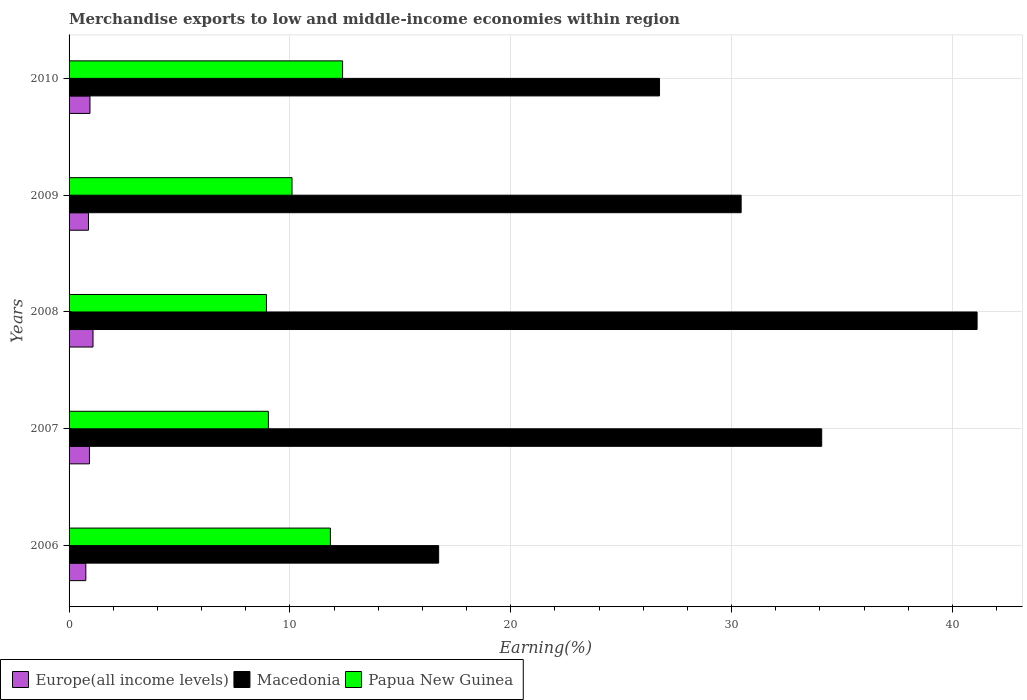How many groups of bars are there?
Your response must be concise. 5. Are the number of bars per tick equal to the number of legend labels?
Give a very brief answer. Yes. Are the number of bars on each tick of the Y-axis equal?
Give a very brief answer. Yes. How many bars are there on the 1st tick from the top?
Keep it short and to the point. 3. How many bars are there on the 4th tick from the bottom?
Offer a very short reply. 3. What is the percentage of amount earned from merchandise exports in Europe(all income levels) in 2008?
Your answer should be compact. 1.08. Across all years, what is the maximum percentage of amount earned from merchandise exports in Papua New Guinea?
Make the answer very short. 12.39. Across all years, what is the minimum percentage of amount earned from merchandise exports in Macedonia?
Make the answer very short. 16.74. In which year was the percentage of amount earned from merchandise exports in Papua New Guinea maximum?
Your answer should be compact. 2010. What is the total percentage of amount earned from merchandise exports in Papua New Guinea in the graph?
Ensure brevity in your answer.  52.28. What is the difference between the percentage of amount earned from merchandise exports in Europe(all income levels) in 2006 and that in 2010?
Give a very brief answer. -0.19. What is the difference between the percentage of amount earned from merchandise exports in Macedonia in 2006 and the percentage of amount earned from merchandise exports in Papua New Guinea in 2010?
Provide a short and direct response. 4.35. What is the average percentage of amount earned from merchandise exports in Papua New Guinea per year?
Keep it short and to the point. 10.46. In the year 2008, what is the difference between the percentage of amount earned from merchandise exports in Papua New Guinea and percentage of amount earned from merchandise exports in Macedonia?
Provide a short and direct response. -32.18. In how many years, is the percentage of amount earned from merchandise exports in Papua New Guinea greater than 24 %?
Provide a short and direct response. 0. What is the ratio of the percentage of amount earned from merchandise exports in Papua New Guinea in 2007 to that in 2009?
Your response must be concise. 0.89. Is the percentage of amount earned from merchandise exports in Papua New Guinea in 2009 less than that in 2010?
Your answer should be very brief. Yes. What is the difference between the highest and the second highest percentage of amount earned from merchandise exports in Europe(all income levels)?
Your answer should be very brief. 0.14. What is the difference between the highest and the lowest percentage of amount earned from merchandise exports in Papua New Guinea?
Provide a short and direct response. 3.45. Is the sum of the percentage of amount earned from merchandise exports in Europe(all income levels) in 2007 and 2010 greater than the maximum percentage of amount earned from merchandise exports in Papua New Guinea across all years?
Offer a terse response. No. What does the 2nd bar from the top in 2006 represents?
Offer a very short reply. Macedonia. What does the 2nd bar from the bottom in 2008 represents?
Provide a succinct answer. Macedonia. Is it the case that in every year, the sum of the percentage of amount earned from merchandise exports in Europe(all income levels) and percentage of amount earned from merchandise exports in Macedonia is greater than the percentage of amount earned from merchandise exports in Papua New Guinea?
Offer a very short reply. Yes. How many bars are there?
Make the answer very short. 15. How many years are there in the graph?
Provide a succinct answer. 5. What is the difference between two consecutive major ticks on the X-axis?
Ensure brevity in your answer.  10. Are the values on the major ticks of X-axis written in scientific E-notation?
Provide a succinct answer. No. Does the graph contain any zero values?
Ensure brevity in your answer.  No. Does the graph contain grids?
Provide a succinct answer. Yes. How many legend labels are there?
Keep it short and to the point. 3. How are the legend labels stacked?
Your answer should be compact. Horizontal. What is the title of the graph?
Offer a terse response. Merchandise exports to low and middle-income economies within region. Does "Kazakhstan" appear as one of the legend labels in the graph?
Provide a succinct answer. No. What is the label or title of the X-axis?
Provide a succinct answer. Earning(%). What is the Earning(%) in Europe(all income levels) in 2006?
Your response must be concise. 0.76. What is the Earning(%) of Macedonia in 2006?
Provide a short and direct response. 16.74. What is the Earning(%) in Papua New Guinea in 2006?
Keep it short and to the point. 11.83. What is the Earning(%) of Europe(all income levels) in 2007?
Your response must be concise. 0.92. What is the Earning(%) of Macedonia in 2007?
Keep it short and to the point. 34.08. What is the Earning(%) in Papua New Guinea in 2007?
Make the answer very short. 9.03. What is the Earning(%) in Europe(all income levels) in 2008?
Your answer should be compact. 1.08. What is the Earning(%) in Macedonia in 2008?
Offer a terse response. 41.12. What is the Earning(%) in Papua New Guinea in 2008?
Give a very brief answer. 8.94. What is the Earning(%) in Europe(all income levels) in 2009?
Your answer should be compact. 0.88. What is the Earning(%) of Macedonia in 2009?
Ensure brevity in your answer.  30.43. What is the Earning(%) in Papua New Guinea in 2009?
Give a very brief answer. 10.1. What is the Earning(%) of Europe(all income levels) in 2010?
Your response must be concise. 0.95. What is the Earning(%) in Macedonia in 2010?
Provide a short and direct response. 26.74. What is the Earning(%) in Papua New Guinea in 2010?
Your answer should be compact. 12.39. Across all years, what is the maximum Earning(%) in Europe(all income levels)?
Give a very brief answer. 1.08. Across all years, what is the maximum Earning(%) of Macedonia?
Make the answer very short. 41.12. Across all years, what is the maximum Earning(%) of Papua New Guinea?
Keep it short and to the point. 12.39. Across all years, what is the minimum Earning(%) in Europe(all income levels)?
Keep it short and to the point. 0.76. Across all years, what is the minimum Earning(%) in Macedonia?
Offer a very short reply. 16.74. Across all years, what is the minimum Earning(%) of Papua New Guinea?
Offer a terse response. 8.94. What is the total Earning(%) in Europe(all income levels) in the graph?
Keep it short and to the point. 4.59. What is the total Earning(%) in Macedonia in the graph?
Give a very brief answer. 149.11. What is the total Earning(%) in Papua New Guinea in the graph?
Offer a terse response. 52.28. What is the difference between the Earning(%) of Europe(all income levels) in 2006 and that in 2007?
Your response must be concise. -0.16. What is the difference between the Earning(%) of Macedonia in 2006 and that in 2007?
Make the answer very short. -17.35. What is the difference between the Earning(%) in Papua New Guinea in 2006 and that in 2007?
Offer a very short reply. 2.81. What is the difference between the Earning(%) of Europe(all income levels) in 2006 and that in 2008?
Make the answer very short. -0.33. What is the difference between the Earning(%) in Macedonia in 2006 and that in 2008?
Offer a very short reply. -24.38. What is the difference between the Earning(%) in Papua New Guinea in 2006 and that in 2008?
Offer a very short reply. 2.89. What is the difference between the Earning(%) in Europe(all income levels) in 2006 and that in 2009?
Offer a terse response. -0.12. What is the difference between the Earning(%) of Macedonia in 2006 and that in 2009?
Make the answer very short. -13.7. What is the difference between the Earning(%) of Papua New Guinea in 2006 and that in 2009?
Offer a very short reply. 1.74. What is the difference between the Earning(%) of Europe(all income levels) in 2006 and that in 2010?
Your answer should be compact. -0.19. What is the difference between the Earning(%) of Macedonia in 2006 and that in 2010?
Your answer should be compact. -10. What is the difference between the Earning(%) of Papua New Guinea in 2006 and that in 2010?
Ensure brevity in your answer.  -0.55. What is the difference between the Earning(%) in Europe(all income levels) in 2007 and that in 2008?
Offer a very short reply. -0.16. What is the difference between the Earning(%) of Macedonia in 2007 and that in 2008?
Your answer should be very brief. -7.04. What is the difference between the Earning(%) of Papua New Guinea in 2007 and that in 2008?
Offer a terse response. 0.09. What is the difference between the Earning(%) in Europe(all income levels) in 2007 and that in 2009?
Your response must be concise. 0.04. What is the difference between the Earning(%) of Macedonia in 2007 and that in 2009?
Ensure brevity in your answer.  3.65. What is the difference between the Earning(%) in Papua New Guinea in 2007 and that in 2009?
Provide a succinct answer. -1.07. What is the difference between the Earning(%) of Europe(all income levels) in 2007 and that in 2010?
Offer a terse response. -0.02. What is the difference between the Earning(%) of Macedonia in 2007 and that in 2010?
Make the answer very short. 7.34. What is the difference between the Earning(%) of Papua New Guinea in 2007 and that in 2010?
Provide a short and direct response. -3.36. What is the difference between the Earning(%) in Europe(all income levels) in 2008 and that in 2009?
Offer a very short reply. 0.2. What is the difference between the Earning(%) in Macedonia in 2008 and that in 2009?
Offer a very short reply. 10.68. What is the difference between the Earning(%) in Papua New Guinea in 2008 and that in 2009?
Your response must be concise. -1.16. What is the difference between the Earning(%) in Europe(all income levels) in 2008 and that in 2010?
Your response must be concise. 0.14. What is the difference between the Earning(%) in Macedonia in 2008 and that in 2010?
Your response must be concise. 14.38. What is the difference between the Earning(%) of Papua New Guinea in 2008 and that in 2010?
Provide a short and direct response. -3.45. What is the difference between the Earning(%) in Europe(all income levels) in 2009 and that in 2010?
Offer a terse response. -0.07. What is the difference between the Earning(%) in Macedonia in 2009 and that in 2010?
Give a very brief answer. 3.7. What is the difference between the Earning(%) of Papua New Guinea in 2009 and that in 2010?
Your response must be concise. -2.29. What is the difference between the Earning(%) of Europe(all income levels) in 2006 and the Earning(%) of Macedonia in 2007?
Give a very brief answer. -33.32. What is the difference between the Earning(%) in Europe(all income levels) in 2006 and the Earning(%) in Papua New Guinea in 2007?
Offer a very short reply. -8.27. What is the difference between the Earning(%) in Macedonia in 2006 and the Earning(%) in Papua New Guinea in 2007?
Provide a succinct answer. 7.71. What is the difference between the Earning(%) of Europe(all income levels) in 2006 and the Earning(%) of Macedonia in 2008?
Your answer should be very brief. -40.36. What is the difference between the Earning(%) of Europe(all income levels) in 2006 and the Earning(%) of Papua New Guinea in 2008?
Provide a short and direct response. -8.18. What is the difference between the Earning(%) in Macedonia in 2006 and the Earning(%) in Papua New Guinea in 2008?
Your answer should be compact. 7.8. What is the difference between the Earning(%) of Europe(all income levels) in 2006 and the Earning(%) of Macedonia in 2009?
Your response must be concise. -29.68. What is the difference between the Earning(%) of Europe(all income levels) in 2006 and the Earning(%) of Papua New Guinea in 2009?
Offer a very short reply. -9.34. What is the difference between the Earning(%) in Macedonia in 2006 and the Earning(%) in Papua New Guinea in 2009?
Offer a very short reply. 6.64. What is the difference between the Earning(%) in Europe(all income levels) in 2006 and the Earning(%) in Macedonia in 2010?
Make the answer very short. -25.98. What is the difference between the Earning(%) of Europe(all income levels) in 2006 and the Earning(%) of Papua New Guinea in 2010?
Offer a terse response. -11.63. What is the difference between the Earning(%) of Macedonia in 2006 and the Earning(%) of Papua New Guinea in 2010?
Ensure brevity in your answer.  4.35. What is the difference between the Earning(%) of Europe(all income levels) in 2007 and the Earning(%) of Macedonia in 2008?
Your response must be concise. -40.2. What is the difference between the Earning(%) in Europe(all income levels) in 2007 and the Earning(%) in Papua New Guinea in 2008?
Provide a short and direct response. -8.02. What is the difference between the Earning(%) of Macedonia in 2007 and the Earning(%) of Papua New Guinea in 2008?
Offer a terse response. 25.14. What is the difference between the Earning(%) of Europe(all income levels) in 2007 and the Earning(%) of Macedonia in 2009?
Keep it short and to the point. -29.51. What is the difference between the Earning(%) of Europe(all income levels) in 2007 and the Earning(%) of Papua New Guinea in 2009?
Provide a succinct answer. -9.17. What is the difference between the Earning(%) of Macedonia in 2007 and the Earning(%) of Papua New Guinea in 2009?
Your answer should be compact. 23.99. What is the difference between the Earning(%) of Europe(all income levels) in 2007 and the Earning(%) of Macedonia in 2010?
Your response must be concise. -25.82. What is the difference between the Earning(%) of Europe(all income levels) in 2007 and the Earning(%) of Papua New Guinea in 2010?
Give a very brief answer. -11.46. What is the difference between the Earning(%) in Macedonia in 2007 and the Earning(%) in Papua New Guinea in 2010?
Your response must be concise. 21.7. What is the difference between the Earning(%) in Europe(all income levels) in 2008 and the Earning(%) in Macedonia in 2009?
Your answer should be compact. -29.35. What is the difference between the Earning(%) in Europe(all income levels) in 2008 and the Earning(%) in Papua New Guinea in 2009?
Your answer should be very brief. -9.01. What is the difference between the Earning(%) of Macedonia in 2008 and the Earning(%) of Papua New Guinea in 2009?
Keep it short and to the point. 31.02. What is the difference between the Earning(%) in Europe(all income levels) in 2008 and the Earning(%) in Macedonia in 2010?
Offer a terse response. -25.66. What is the difference between the Earning(%) in Europe(all income levels) in 2008 and the Earning(%) in Papua New Guinea in 2010?
Keep it short and to the point. -11.3. What is the difference between the Earning(%) in Macedonia in 2008 and the Earning(%) in Papua New Guinea in 2010?
Ensure brevity in your answer.  28.73. What is the difference between the Earning(%) of Europe(all income levels) in 2009 and the Earning(%) of Macedonia in 2010?
Ensure brevity in your answer.  -25.86. What is the difference between the Earning(%) in Europe(all income levels) in 2009 and the Earning(%) in Papua New Guinea in 2010?
Your answer should be compact. -11.51. What is the difference between the Earning(%) in Macedonia in 2009 and the Earning(%) in Papua New Guinea in 2010?
Give a very brief answer. 18.05. What is the average Earning(%) of Europe(all income levels) per year?
Your answer should be compact. 0.92. What is the average Earning(%) in Macedonia per year?
Your answer should be very brief. 29.82. What is the average Earning(%) in Papua New Guinea per year?
Make the answer very short. 10.46. In the year 2006, what is the difference between the Earning(%) in Europe(all income levels) and Earning(%) in Macedonia?
Your response must be concise. -15.98. In the year 2006, what is the difference between the Earning(%) of Europe(all income levels) and Earning(%) of Papua New Guinea?
Your answer should be very brief. -11.07. In the year 2006, what is the difference between the Earning(%) in Macedonia and Earning(%) in Papua New Guinea?
Provide a short and direct response. 4.9. In the year 2007, what is the difference between the Earning(%) in Europe(all income levels) and Earning(%) in Macedonia?
Provide a succinct answer. -33.16. In the year 2007, what is the difference between the Earning(%) of Europe(all income levels) and Earning(%) of Papua New Guinea?
Offer a very short reply. -8.1. In the year 2007, what is the difference between the Earning(%) of Macedonia and Earning(%) of Papua New Guinea?
Give a very brief answer. 25.06. In the year 2008, what is the difference between the Earning(%) in Europe(all income levels) and Earning(%) in Macedonia?
Offer a terse response. -40.04. In the year 2008, what is the difference between the Earning(%) in Europe(all income levels) and Earning(%) in Papua New Guinea?
Offer a very short reply. -7.85. In the year 2008, what is the difference between the Earning(%) in Macedonia and Earning(%) in Papua New Guinea?
Provide a succinct answer. 32.18. In the year 2009, what is the difference between the Earning(%) of Europe(all income levels) and Earning(%) of Macedonia?
Ensure brevity in your answer.  -29.56. In the year 2009, what is the difference between the Earning(%) of Europe(all income levels) and Earning(%) of Papua New Guinea?
Provide a short and direct response. -9.22. In the year 2009, what is the difference between the Earning(%) of Macedonia and Earning(%) of Papua New Guinea?
Offer a very short reply. 20.34. In the year 2010, what is the difference between the Earning(%) in Europe(all income levels) and Earning(%) in Macedonia?
Your answer should be compact. -25.79. In the year 2010, what is the difference between the Earning(%) in Europe(all income levels) and Earning(%) in Papua New Guinea?
Provide a succinct answer. -11.44. In the year 2010, what is the difference between the Earning(%) in Macedonia and Earning(%) in Papua New Guinea?
Provide a short and direct response. 14.35. What is the ratio of the Earning(%) of Europe(all income levels) in 2006 to that in 2007?
Provide a succinct answer. 0.82. What is the ratio of the Earning(%) in Macedonia in 2006 to that in 2007?
Offer a very short reply. 0.49. What is the ratio of the Earning(%) of Papua New Guinea in 2006 to that in 2007?
Offer a very short reply. 1.31. What is the ratio of the Earning(%) in Europe(all income levels) in 2006 to that in 2008?
Your answer should be very brief. 0.7. What is the ratio of the Earning(%) in Macedonia in 2006 to that in 2008?
Provide a succinct answer. 0.41. What is the ratio of the Earning(%) of Papua New Guinea in 2006 to that in 2008?
Provide a succinct answer. 1.32. What is the ratio of the Earning(%) in Europe(all income levels) in 2006 to that in 2009?
Give a very brief answer. 0.86. What is the ratio of the Earning(%) in Macedonia in 2006 to that in 2009?
Your response must be concise. 0.55. What is the ratio of the Earning(%) in Papua New Guinea in 2006 to that in 2009?
Give a very brief answer. 1.17. What is the ratio of the Earning(%) in Europe(all income levels) in 2006 to that in 2010?
Keep it short and to the point. 0.8. What is the ratio of the Earning(%) in Macedonia in 2006 to that in 2010?
Your answer should be compact. 0.63. What is the ratio of the Earning(%) in Papua New Guinea in 2006 to that in 2010?
Offer a very short reply. 0.96. What is the ratio of the Earning(%) of Europe(all income levels) in 2007 to that in 2008?
Offer a terse response. 0.85. What is the ratio of the Earning(%) of Macedonia in 2007 to that in 2008?
Offer a terse response. 0.83. What is the ratio of the Earning(%) of Papua New Guinea in 2007 to that in 2008?
Your answer should be compact. 1.01. What is the ratio of the Earning(%) in Europe(all income levels) in 2007 to that in 2009?
Provide a short and direct response. 1.05. What is the ratio of the Earning(%) in Macedonia in 2007 to that in 2009?
Provide a short and direct response. 1.12. What is the ratio of the Earning(%) of Papua New Guinea in 2007 to that in 2009?
Your answer should be very brief. 0.89. What is the ratio of the Earning(%) in Europe(all income levels) in 2007 to that in 2010?
Make the answer very short. 0.98. What is the ratio of the Earning(%) of Macedonia in 2007 to that in 2010?
Offer a terse response. 1.27. What is the ratio of the Earning(%) in Papua New Guinea in 2007 to that in 2010?
Your answer should be compact. 0.73. What is the ratio of the Earning(%) of Europe(all income levels) in 2008 to that in 2009?
Provide a short and direct response. 1.23. What is the ratio of the Earning(%) of Macedonia in 2008 to that in 2009?
Make the answer very short. 1.35. What is the ratio of the Earning(%) of Papua New Guinea in 2008 to that in 2009?
Your response must be concise. 0.89. What is the ratio of the Earning(%) of Europe(all income levels) in 2008 to that in 2010?
Your response must be concise. 1.15. What is the ratio of the Earning(%) of Macedonia in 2008 to that in 2010?
Give a very brief answer. 1.54. What is the ratio of the Earning(%) in Papua New Guinea in 2008 to that in 2010?
Provide a succinct answer. 0.72. What is the ratio of the Earning(%) of Europe(all income levels) in 2009 to that in 2010?
Make the answer very short. 0.93. What is the ratio of the Earning(%) in Macedonia in 2009 to that in 2010?
Ensure brevity in your answer.  1.14. What is the ratio of the Earning(%) of Papua New Guinea in 2009 to that in 2010?
Offer a very short reply. 0.82. What is the difference between the highest and the second highest Earning(%) of Europe(all income levels)?
Ensure brevity in your answer.  0.14. What is the difference between the highest and the second highest Earning(%) of Macedonia?
Your answer should be very brief. 7.04. What is the difference between the highest and the second highest Earning(%) in Papua New Guinea?
Provide a short and direct response. 0.55. What is the difference between the highest and the lowest Earning(%) in Europe(all income levels)?
Offer a very short reply. 0.33. What is the difference between the highest and the lowest Earning(%) in Macedonia?
Give a very brief answer. 24.38. What is the difference between the highest and the lowest Earning(%) of Papua New Guinea?
Provide a succinct answer. 3.45. 